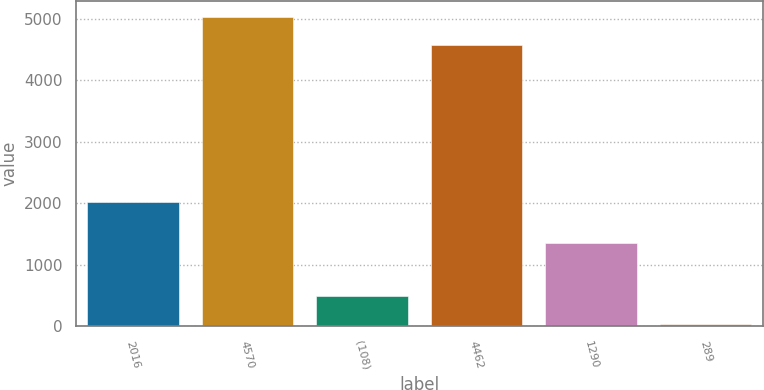Convert chart to OTSL. <chart><loc_0><loc_0><loc_500><loc_500><bar_chart><fcel>2016<fcel>4570<fcel>(108)<fcel>4462<fcel>1290<fcel>289<nl><fcel>2016<fcel>5030.44<fcel>494.04<fcel>4566<fcel>1352<fcel>29.6<nl></chart> 